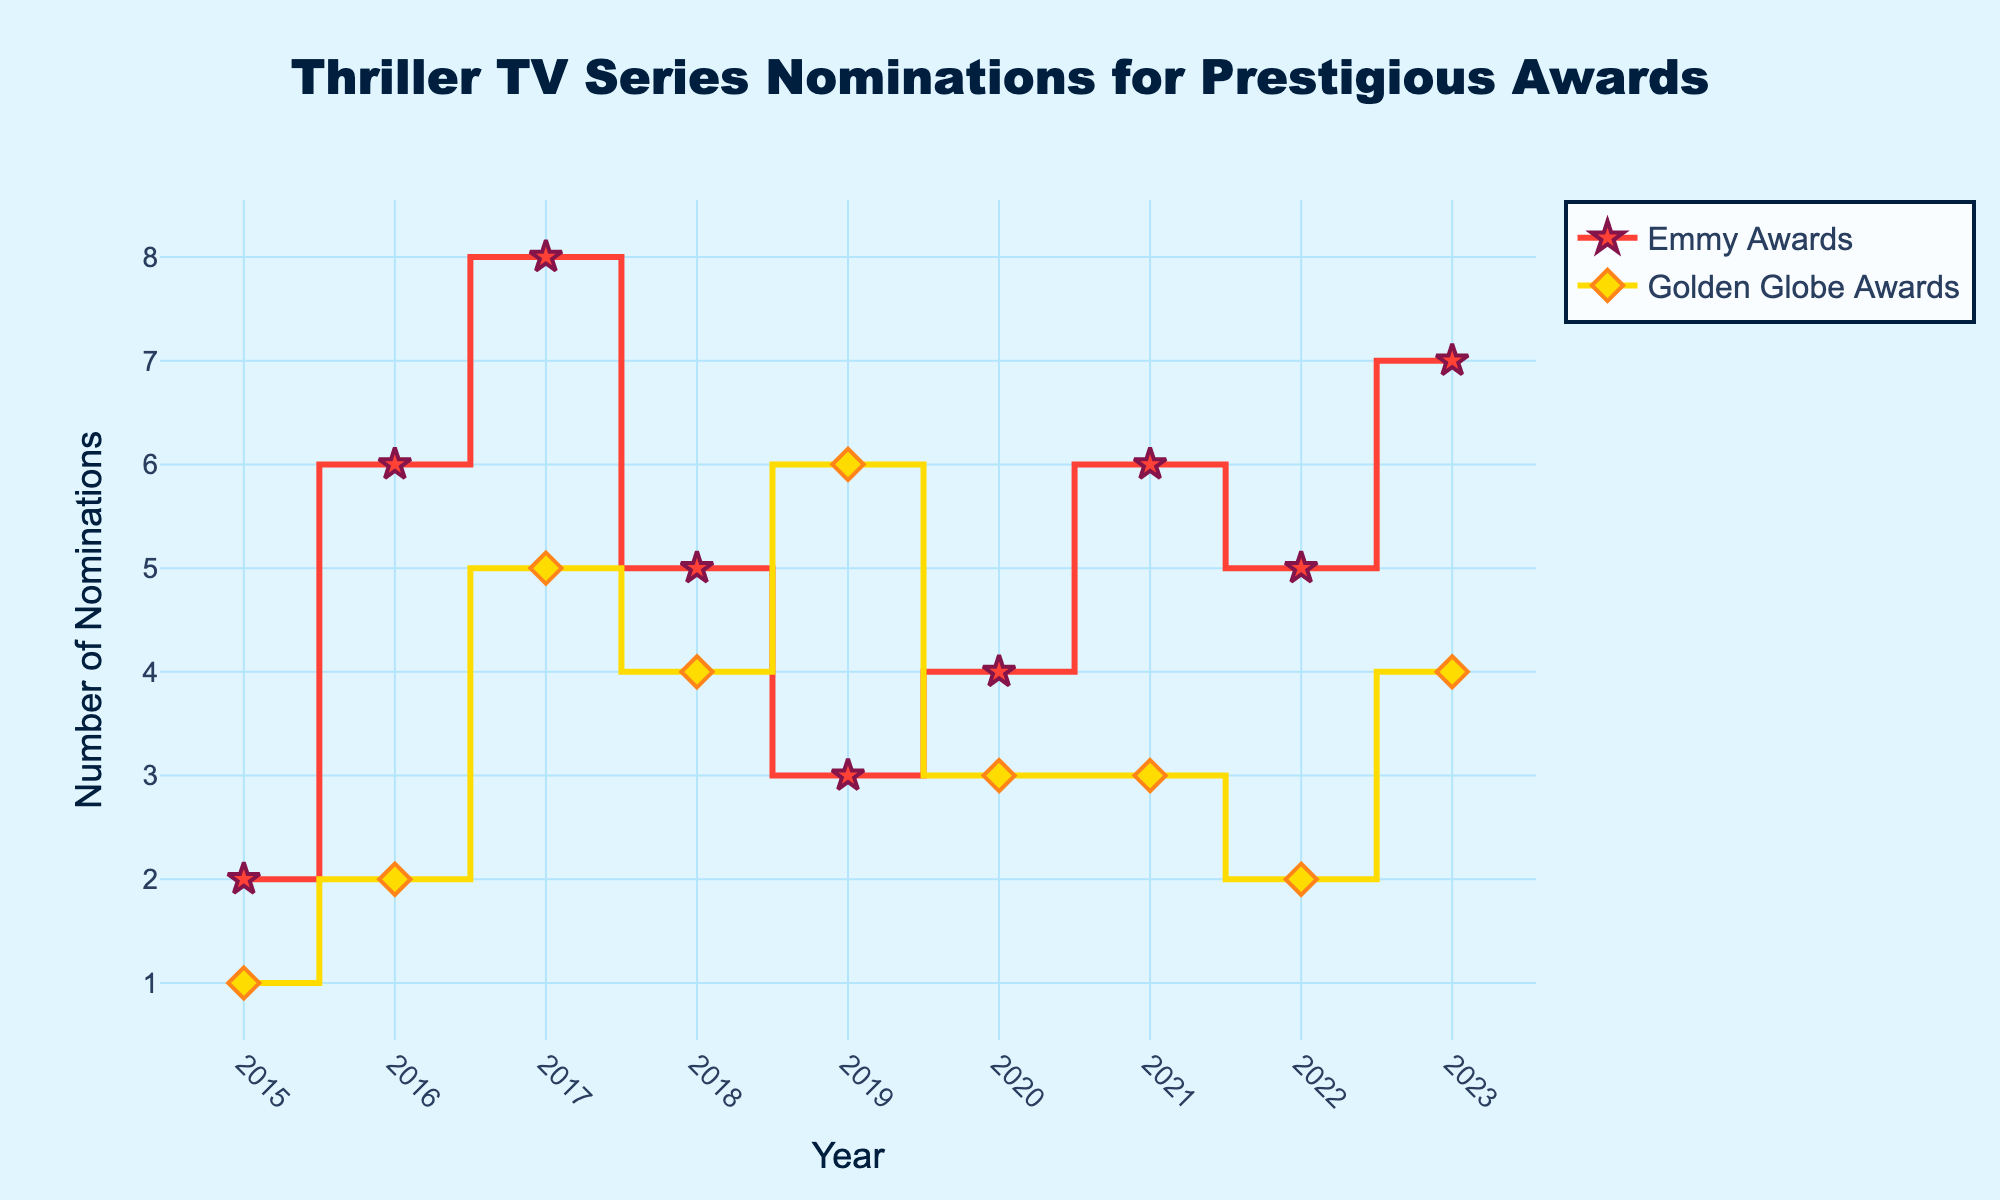Which year had the highest number of Emmy Award nominations for a thriller TV series? Look at the highest point on the red 'stair' line representing Emmy Award nominations. In 2017, "The Handmaid's Tale" received 8 nominations, which is the highest value in the plot for Emmy Awards.
Answer: 2017 How many nominations did "Narcos" receive for an Emmy Award in 2015? Locate the year 2015 on the x-axis and then follow it up to the red stars, which represent Emmy Award nominations. "Narcos" had 2 nominations in 2015.
Answer: 2 Between 2016 and 2020, which series received the most nominations for a Golden Globe Award? Check the yellow 'stair' line for Golden Globe nominations between 2016 and 2020. In 2019, "Chernobyl" had the highest at 6 nominations.
Answer: Chernobyl What is the total number of Golden Globe nominations for thrillers in 2021 and 2023 combined? Find the nominations for 2021 ("Squid Game" with 3) and 2023 ("Casino Royale (TV series)" with 4) on the yellow 'stair' line, and then sum them up: 3 + 4 = 7.
Answer: 7 Compare the nominations for "Mare of Easttown" and "Ozark" and identify which one received more overall nominations. "Mare of Easttown" (2021) received 6 Emmy and 3 Golden Globe nominations; total 9. "Ozark" (2018) received 0 Emmy nominations (not highlighted) and 4 Golden Globe nominations; total 4. "Mare of Easttown" had more.
Answer: Mare of Easttown In which year did the nominations for Emmy and Golden Globe Awards match in number for a thriller TV series? Check where the red and yellow lines align vertically. In 2020, "The Outsider" had 4 Emmy nominations and "The Undoing" had 3 Golden Globe nominations, so no match. However, in 2021, "Mare of Easttown" (6 nominations) and "Squid Game" (3 nominations) also don't match. Hence, no exact match year exists based on the provided data.
Answer: None Which had higher Emmy nominations in 2022: "Severance" or "Mindhunter" in 2019? Look at the red points for 2019 and 2022. "Mindhunter" had 3 in 2019 and "Severance" had 5 in 2022. "Severance" had higher nominations.
Answer: Severance What is the trend in the total number of Emmy nominations from 2015 to 2023? Observe the overall direction of the Emmy (red) line from 2015 to 2023. It fluctuates but generally shows an increasing trend, especially notable in later years like 2021 and 2023.
Answer: Increasing Which specific year shows the largest difference between Emmy and Golden Globe nominations? Identify the year with the biggest gap between the red and yellow lines. In 2017, "The Handmaid’s Tale" had 8 Emmy nominations whereas "Big Little Lies" had 5 Golden Globe nominations, a difference of 3.
Answer: 2017 Which series had exactly 4 nominations for an Emmy Award? Locate points on the red line where the value equals 4. "The Outsider" in 2020 had exactly 4 Emmy nominations.
Answer: The Outsider 